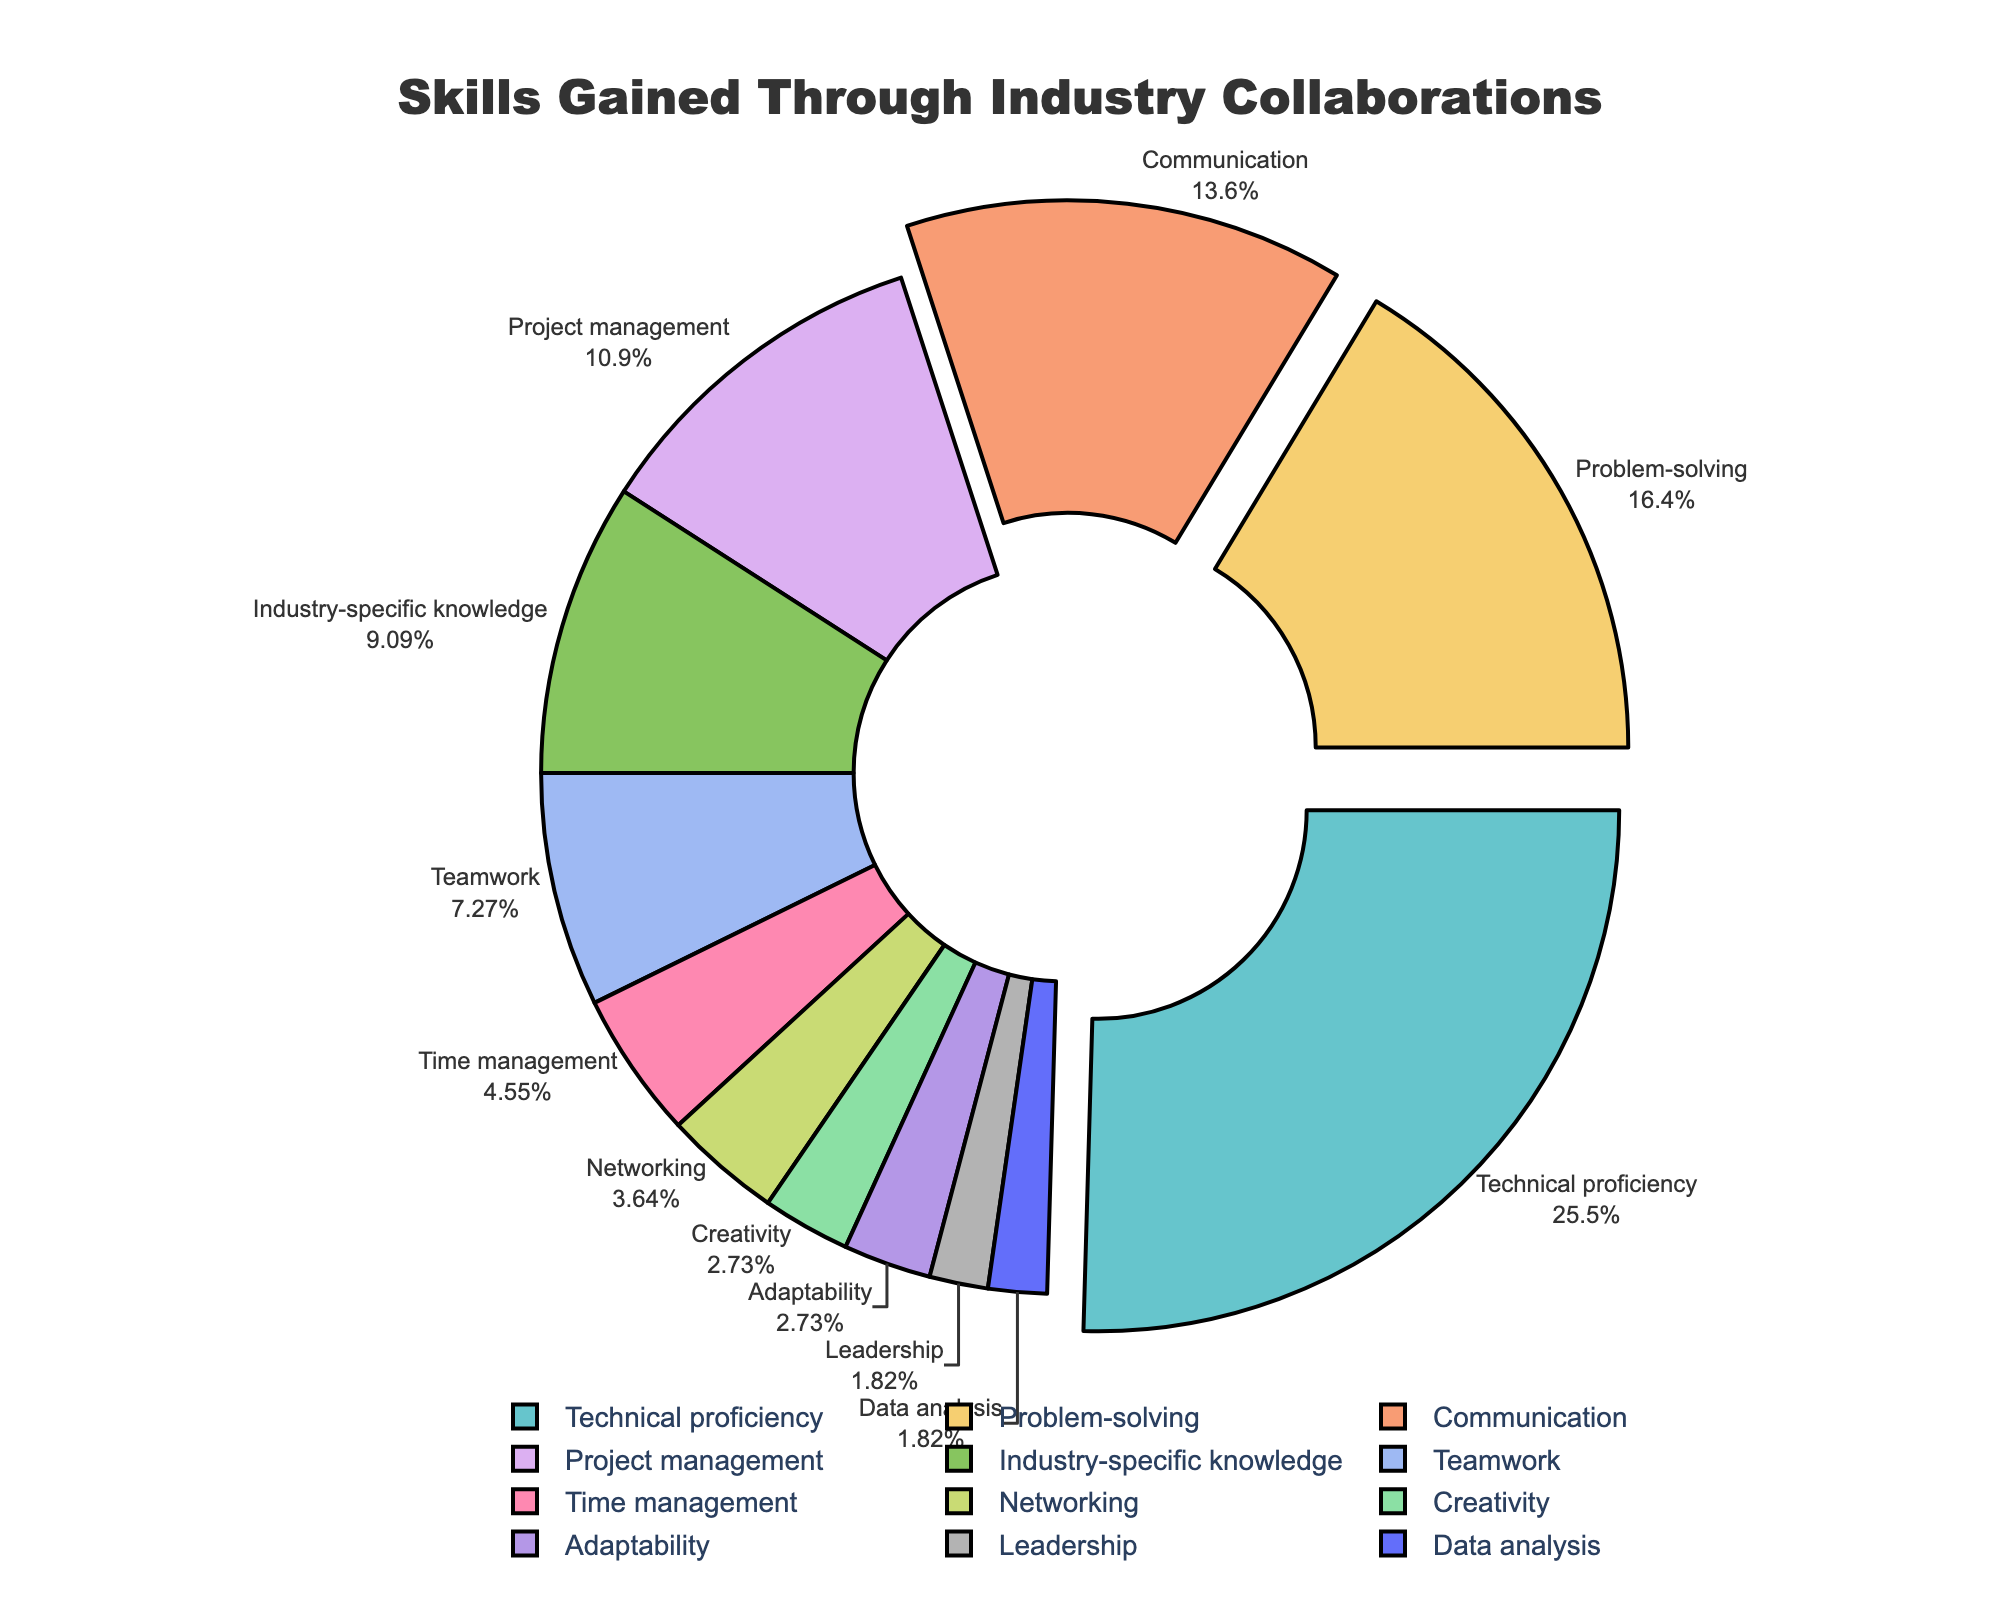What is the percentage of students who gained problem-solving skills? Look at the slice labeled "Problem-solving" in the pie chart. The label indicates the percentage.
Answer: 18% Which skill has the highest percentage? Examine the largest slice in the pie chart. The label on this slice shows the skill and its percentage.
Answer: Technical proficiency What is the sum of the percentages for Technical proficiency and Communication? Find the slices labeled "Technical proficiency" and "Communication". Add their percentages: 28% + 15% = 43%
Answer: 43% Is the percentage of students who gained leadership skills greater than, less than, or equal to the percentage of students who gained data analysis skills? Compare the slices labeled "Leadership" and "Data analysis". Both slices have the same percentage since their labels both show 2%.
Answer: Equal to Which skills were gained by less than 5% of the students? Identify the slices with percentages less than 5%. The labels on these slices show the skills.
Answer: Networking, Creativity, Adaptability, Leadership, Data analysis Which skills have a greater percentage than Project management but less than Technical proficiency? Project management is 12% and Technical proficiency is 28%. Locate slices within this range and note their labels.
Answer: Problem-solving, Communication What is the total percentage of students who gained Teamwork, Time management, and Adaptability skills? Add the percentages of the slices labeled "Teamwork", "Time management", and "Adaptability": 8% + 5% + 3% = 16%
Answer: 16% How much more (or less) is the percentage of students who gained Industry-specific knowledge compared to those who gained Project management skills? Find the difference between the percentages: Project management (12%) - Industry-specific knowledge (10%) = 2%
Answer: 2% less Which skills have percentages that add up to approximately 50%? Select slices whose percentages sum to approximately 50. Technical proficiency (28%), Problem-solving (18%), and Communication (15%) together sum to 61%. Adjust the selection: Technical proficiency (28%) + Project management (12%) + Industry-specific knowledge (10%) = 50% exactly.
Answer: Technical proficiency, Project management, Industry-specific knowledge 